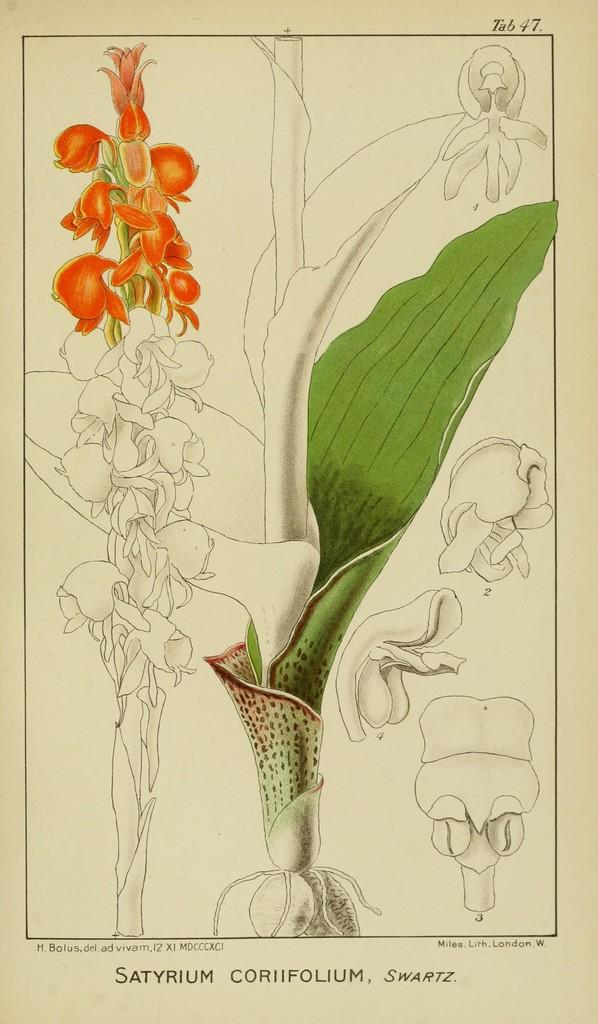What is the main subject of the image? There is a picture in the image. What can be seen in the picture? The picture contains images of plants. What type of parcel is being delivered to the plants in the image? There is no parcel being delivered to the plants in the image; it only contains images of plants. What kind of polish is being applied to the leaves of the plants in the image? There is no polish being applied to the leaves of the plants in the image; it only contains images of plants. 